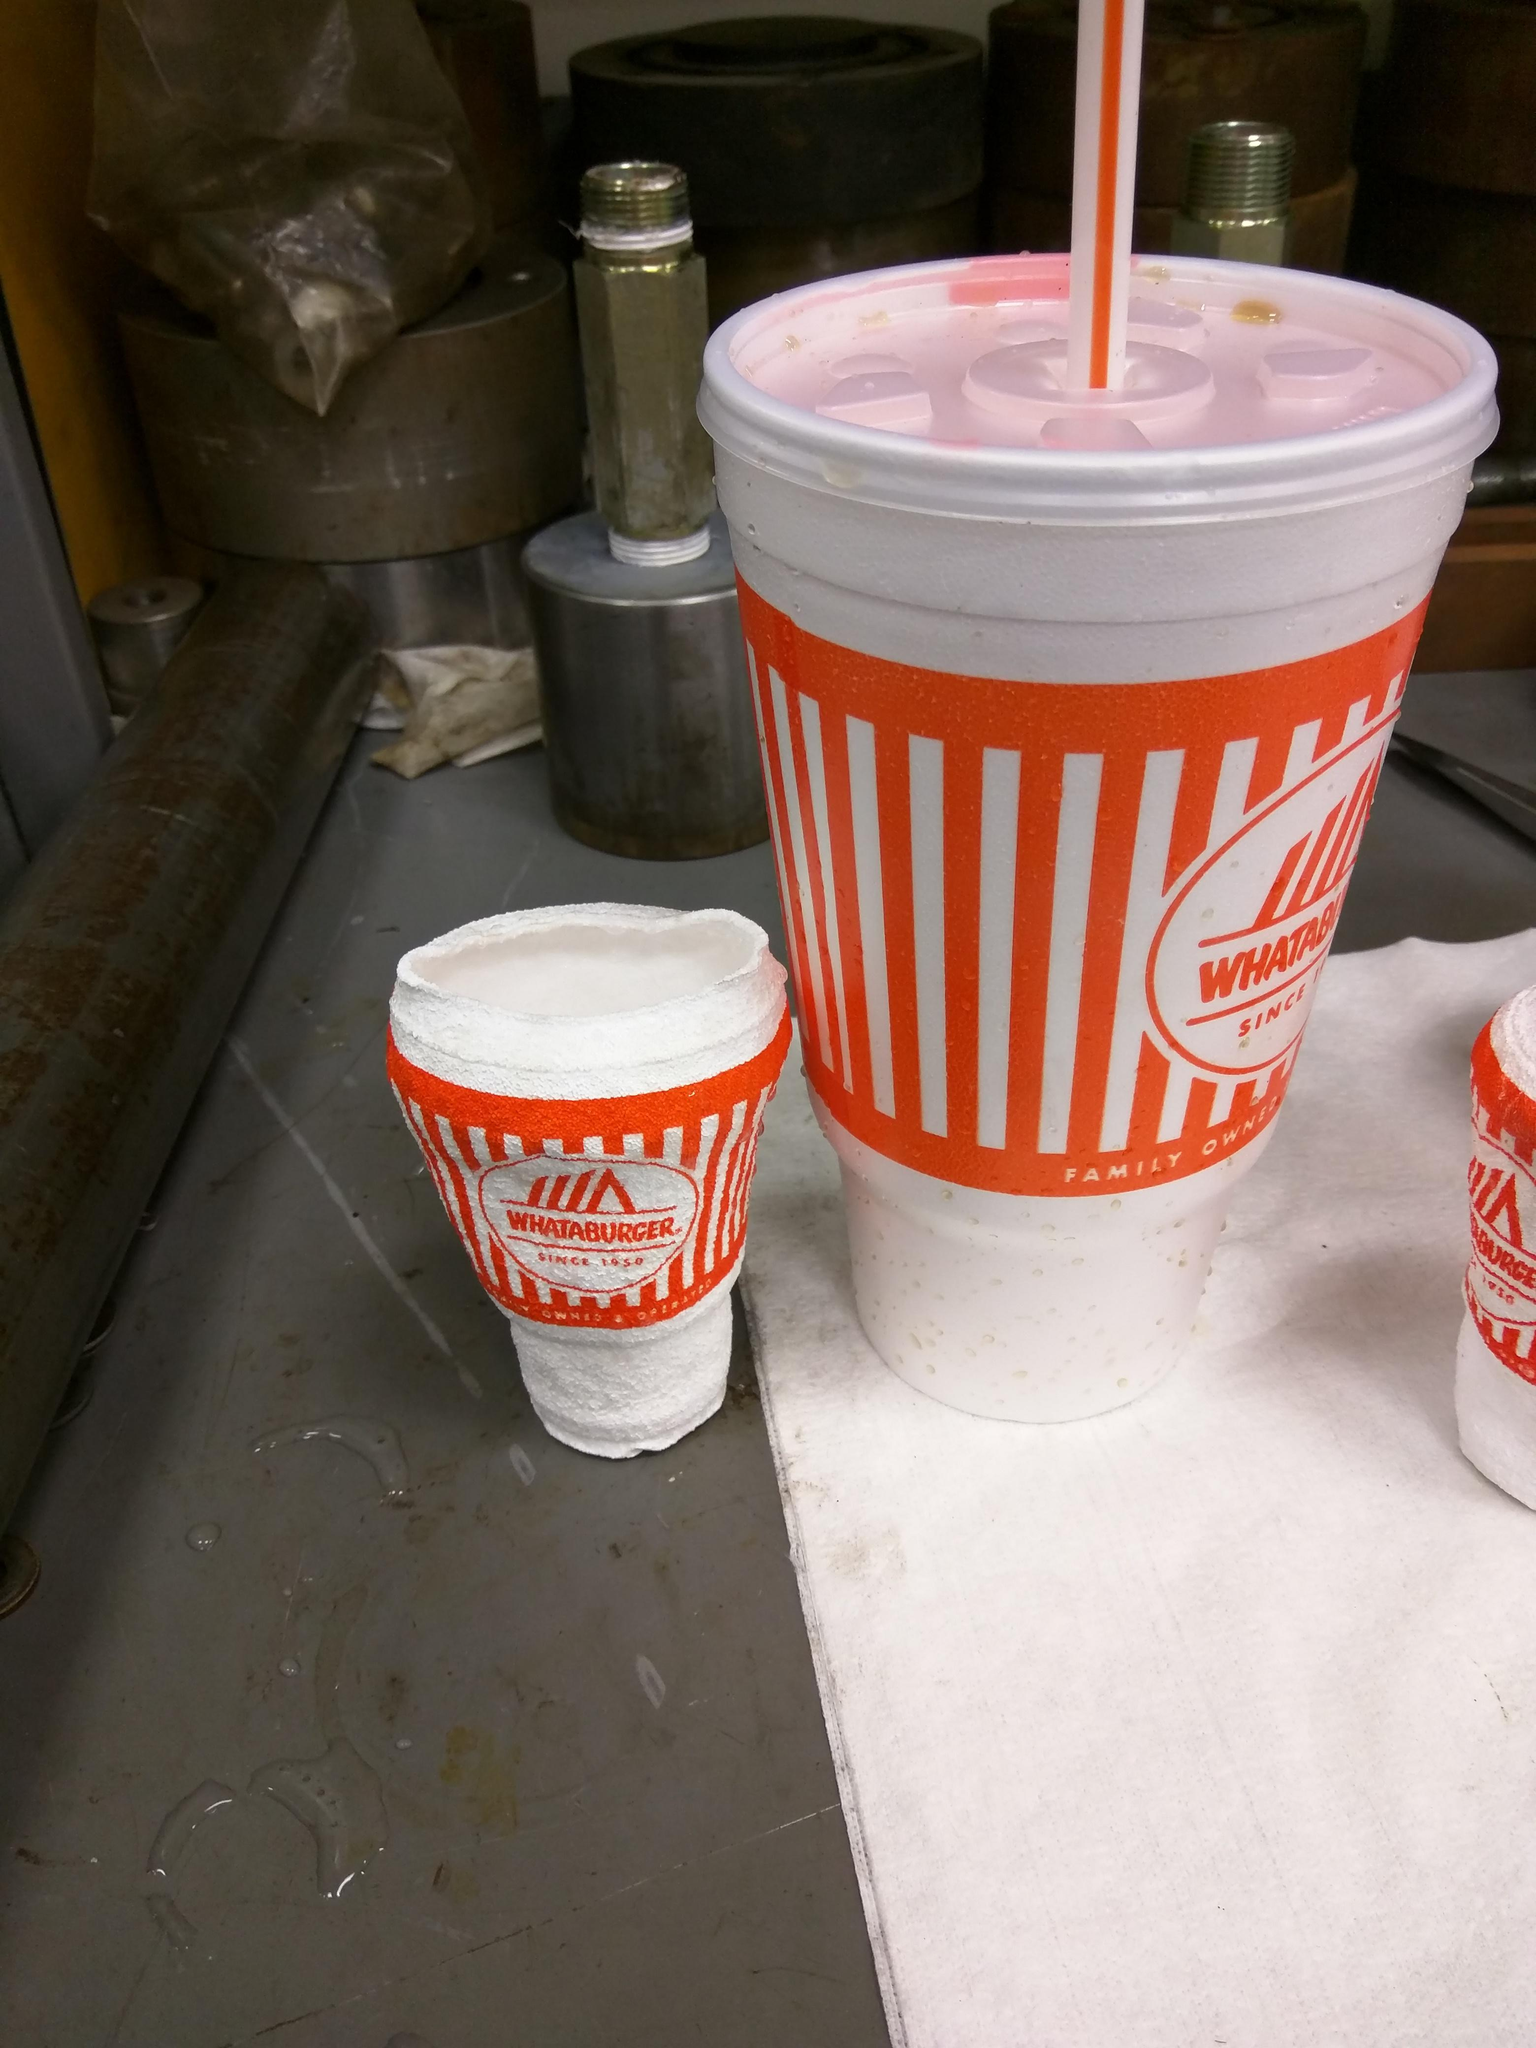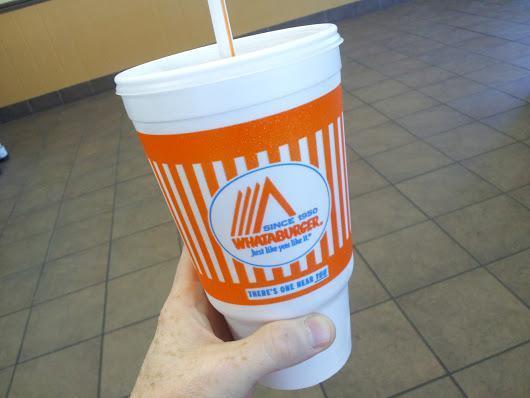The first image is the image on the left, the second image is the image on the right. Assess this claim about the two images: "The right image shows a """"Whataburger"""" cup sitting on a surface.". Correct or not? Answer yes or no. No. 